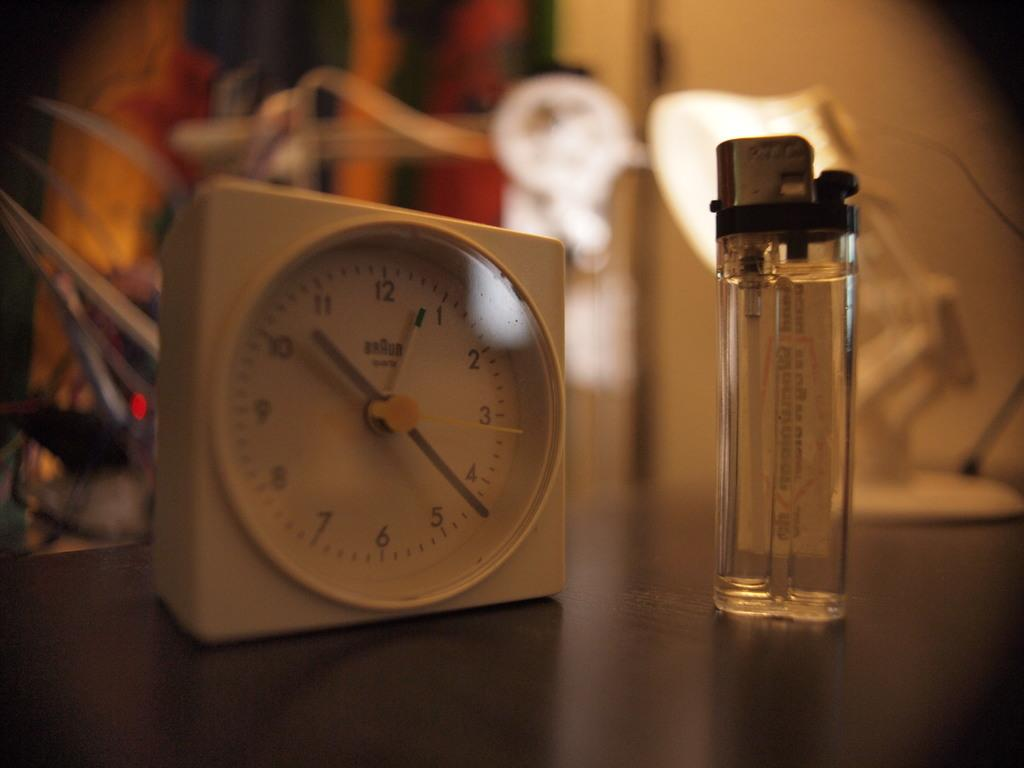<image>
Describe the image concisely. A small white Braun brand clock sits next to a lighter on a table. 